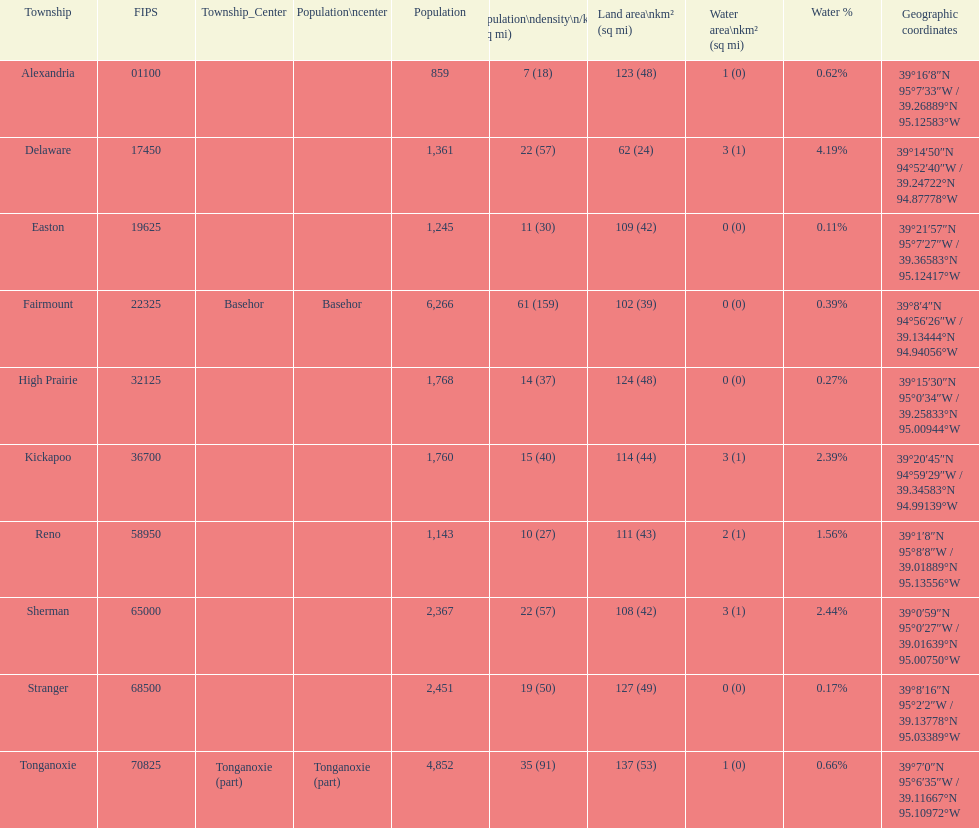Does alexandria county have a higher or lower population than delaware county? Lower. 